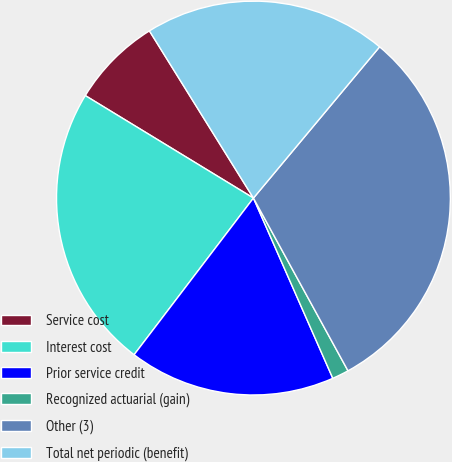Convert chart. <chart><loc_0><loc_0><loc_500><loc_500><pie_chart><fcel>Service cost<fcel>Interest cost<fcel>Prior service credit<fcel>Recognized actuarial (gain)<fcel>Other (3)<fcel>Total net periodic (benefit)<nl><fcel>7.43%<fcel>23.35%<fcel>16.96%<fcel>1.37%<fcel>30.96%<fcel>19.92%<nl></chart> 